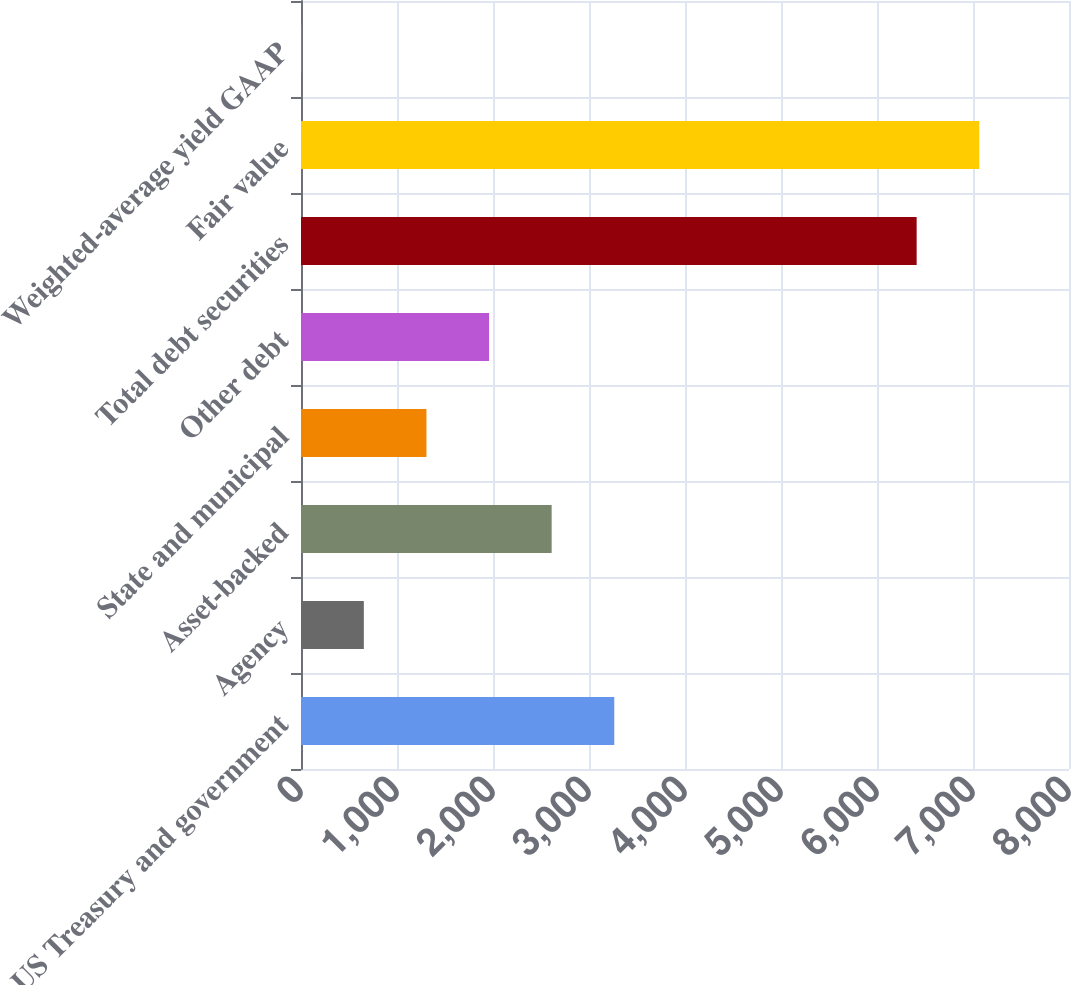Convert chart. <chart><loc_0><loc_0><loc_500><loc_500><bar_chart><fcel>US Treasury and government<fcel>Agency<fcel>Asset-backed<fcel>State and municipal<fcel>Other debt<fcel>Total debt securities<fcel>Fair value<fcel>Weighted-average yield GAAP<nl><fcel>3263.16<fcel>654.52<fcel>2611<fcel>1306.68<fcel>1958.84<fcel>6413<fcel>7065.16<fcel>2.36<nl></chart> 